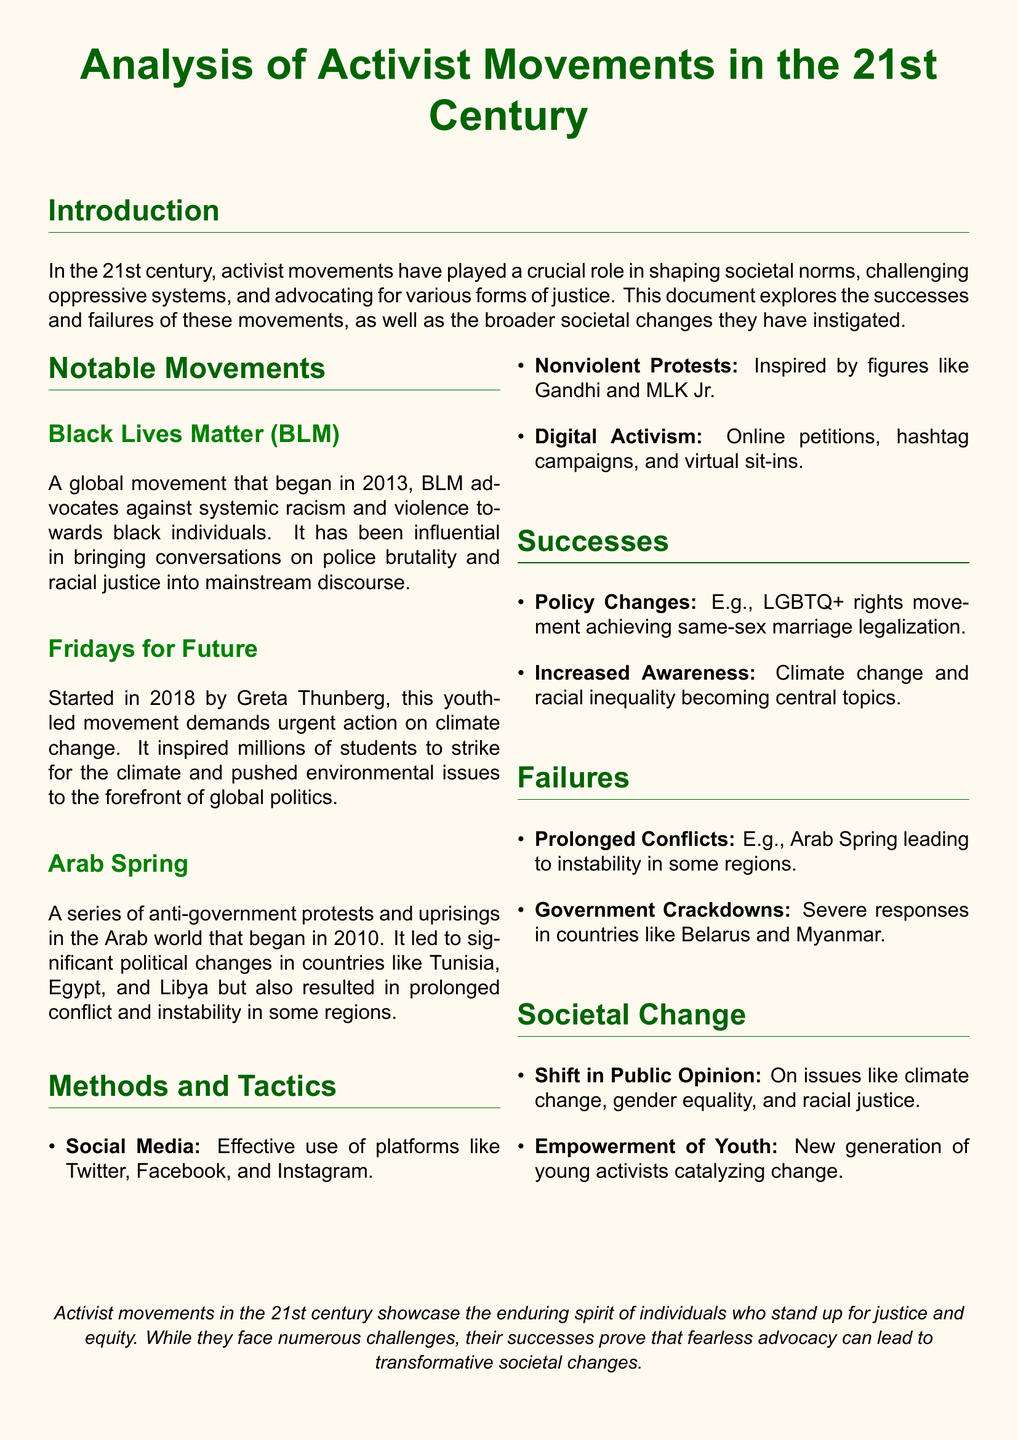What movement began in 2013? The document states that Black Lives Matter started in 2013, advocating against systemic racism and violence.
Answer: Black Lives Matter Who initiated Fridays for Future? The document mentions Greta Thunberg as the initiator of Fridays for Future, a youth-led climate movement.
Answer: Greta Thunberg In which year did the Arab Spring begin? The document notes that the Arab Spring started in 2010 as a series of protests and uprisings.
Answer: 2010 What tactic is inspired by Gandhi and MLK Jr.? The document identifies nonviolent protests as a tactic inspired by these historical figures.
Answer: Nonviolent Protests What is a notable failure of activist movements mentioned? The document lists prolonged conflicts resulting from the Arab Spring as a notable failure of activist movements.
Answer: Prolonged Conflicts What effect did activist movements have on public opinion regarding climate change? The document states there was a shift in public opinion on issues like climate change due to activist movements.
Answer: Shift in Public Opinion What type of activism includes online petitions? The document describes digital activism as including online petitions and hashtag campaigns.
Answer: Digital Activism What significant policy change was achieved by the LGBTQ+ rights movement? The document mentions the legalization of same-sex marriage as a significant policy change achieved.
Answer: Same-sex marriage legalization 